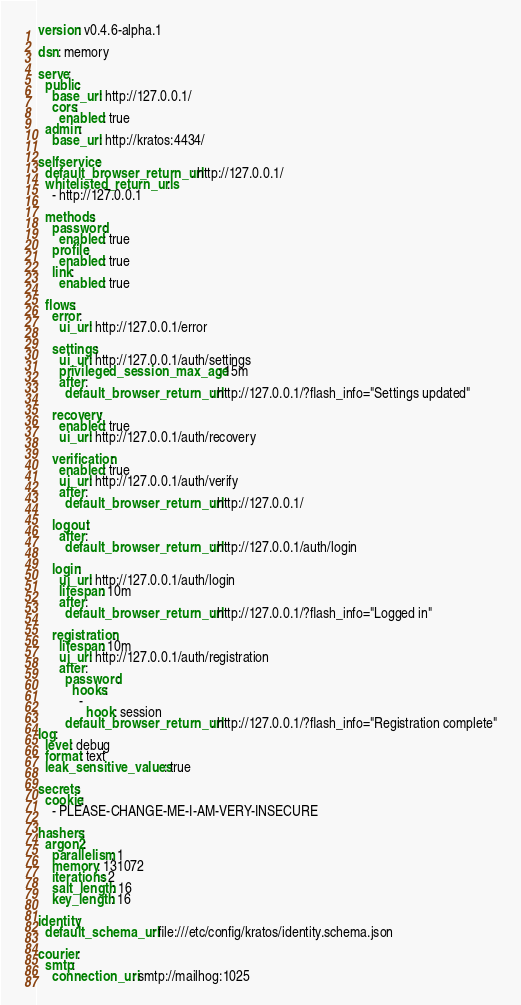Convert code to text. <code><loc_0><loc_0><loc_500><loc_500><_YAML_>version: v0.4.6-alpha.1

dsn: memory

serve:
  public:
    base_url: http://127.0.0.1/
    cors:
      enabled: true
  admin:
    base_url: http://kratos:4434/

selfservice:
  default_browser_return_url: http://127.0.0.1/
  whitelisted_return_urls:
    - http://127.0.0.1

  methods:
    password:
      enabled: true
    profile:
      enabled: true
    link:
      enabled: true

  flows:
    error:
      ui_url: http://127.0.0.1/error

    settings:
      ui_url: http://127.0.0.1/auth/settings
      privileged_session_max_age: 15m
      after:
        default_browser_return_url: http://127.0.0.1/?flash_info="Settings updated"

    recovery:
      enabled: true
      ui_url: http://127.0.0.1/auth/recovery

    verification:
      enabled: true
      ui_url: http://127.0.0.1/auth/verify
      after:
        default_browser_return_url: http://127.0.0.1/

    logout:
      after:
        default_browser_return_url: http://127.0.0.1/auth/login

    login:
      ui_url: http://127.0.0.1/auth/login
      lifespan: 10m
      after:
        default_browser_return_url: http://127.0.0.1/?flash_info="Logged in"

    registration:
      lifespan: 10m
      ui_url: http://127.0.0.1/auth/registration
      after:
        password:
          hooks:
            -
              hook: session
        default_browser_return_url: http://127.0.0.1/?flash_info="Registration complete"
log:
  level: debug
  format: text
  leak_sensitive_values: true

secrets:
  cookie:
    - PLEASE-CHANGE-ME-I-AM-VERY-INSECURE

hashers:
  argon2:
    parallelism: 1
    memory: 131072
    iterations: 2
    salt_length: 16
    key_length: 16

identity:
  default_schema_url: file:///etc/config/kratos/identity.schema.json

courier:
  smtp:
    connection_uri: smtp://mailhog:1025
</code> 